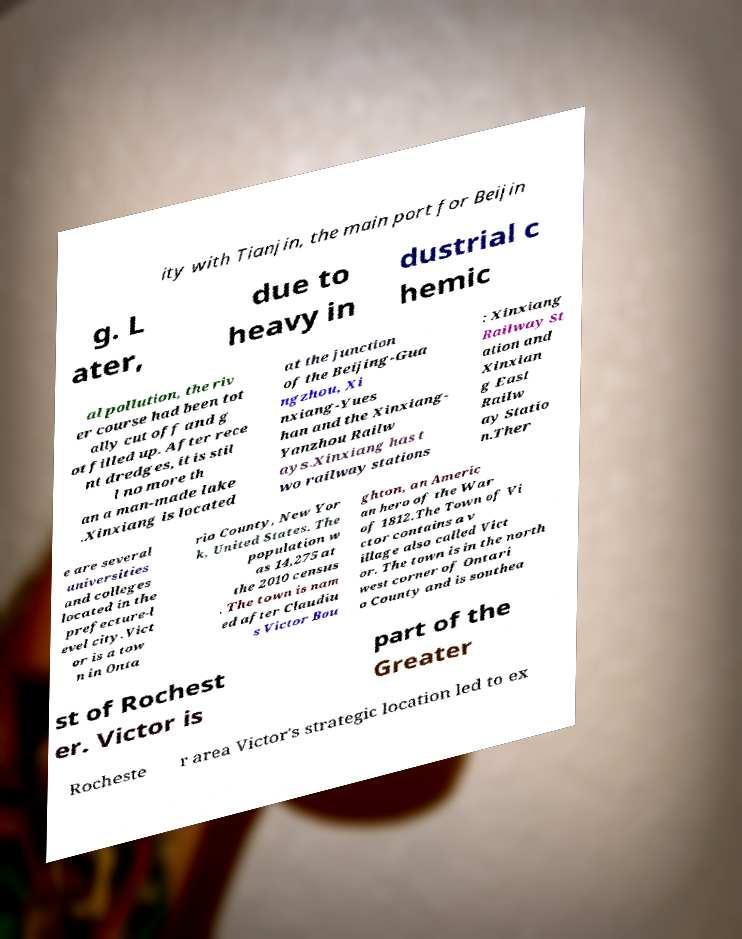Could you extract and type out the text from this image? ity with Tianjin, the main port for Beijin g. L ater, due to heavy in dustrial c hemic al pollution, the riv er course had been tot ally cut off and g ot filled up. After rece nt dredges, it is stil l no more th an a man-made lake .Xinxiang is located at the junction of the Beijing-Gua ngzhou, Xi nxiang-Yues han and the Xinxiang- Yanzhou Railw ays.Xinxiang has t wo railway stations : Xinxiang Railway St ation and Xinxian g East Railw ay Statio n.Ther e are several universities and colleges located in the prefecture-l evel city.Vict or is a tow n in Onta rio County, New Yor k, United States. The population w as 14,275 at the 2010 census . The town is nam ed after Claudiu s Victor Bou ghton, an Americ an hero of the War of 1812.The Town of Vi ctor contains a v illage also called Vict or. The town is in the north west corner of Ontari o County and is southea st of Rochest er. Victor is part of the Greater Rocheste r area Victor's strategic location led to ex 